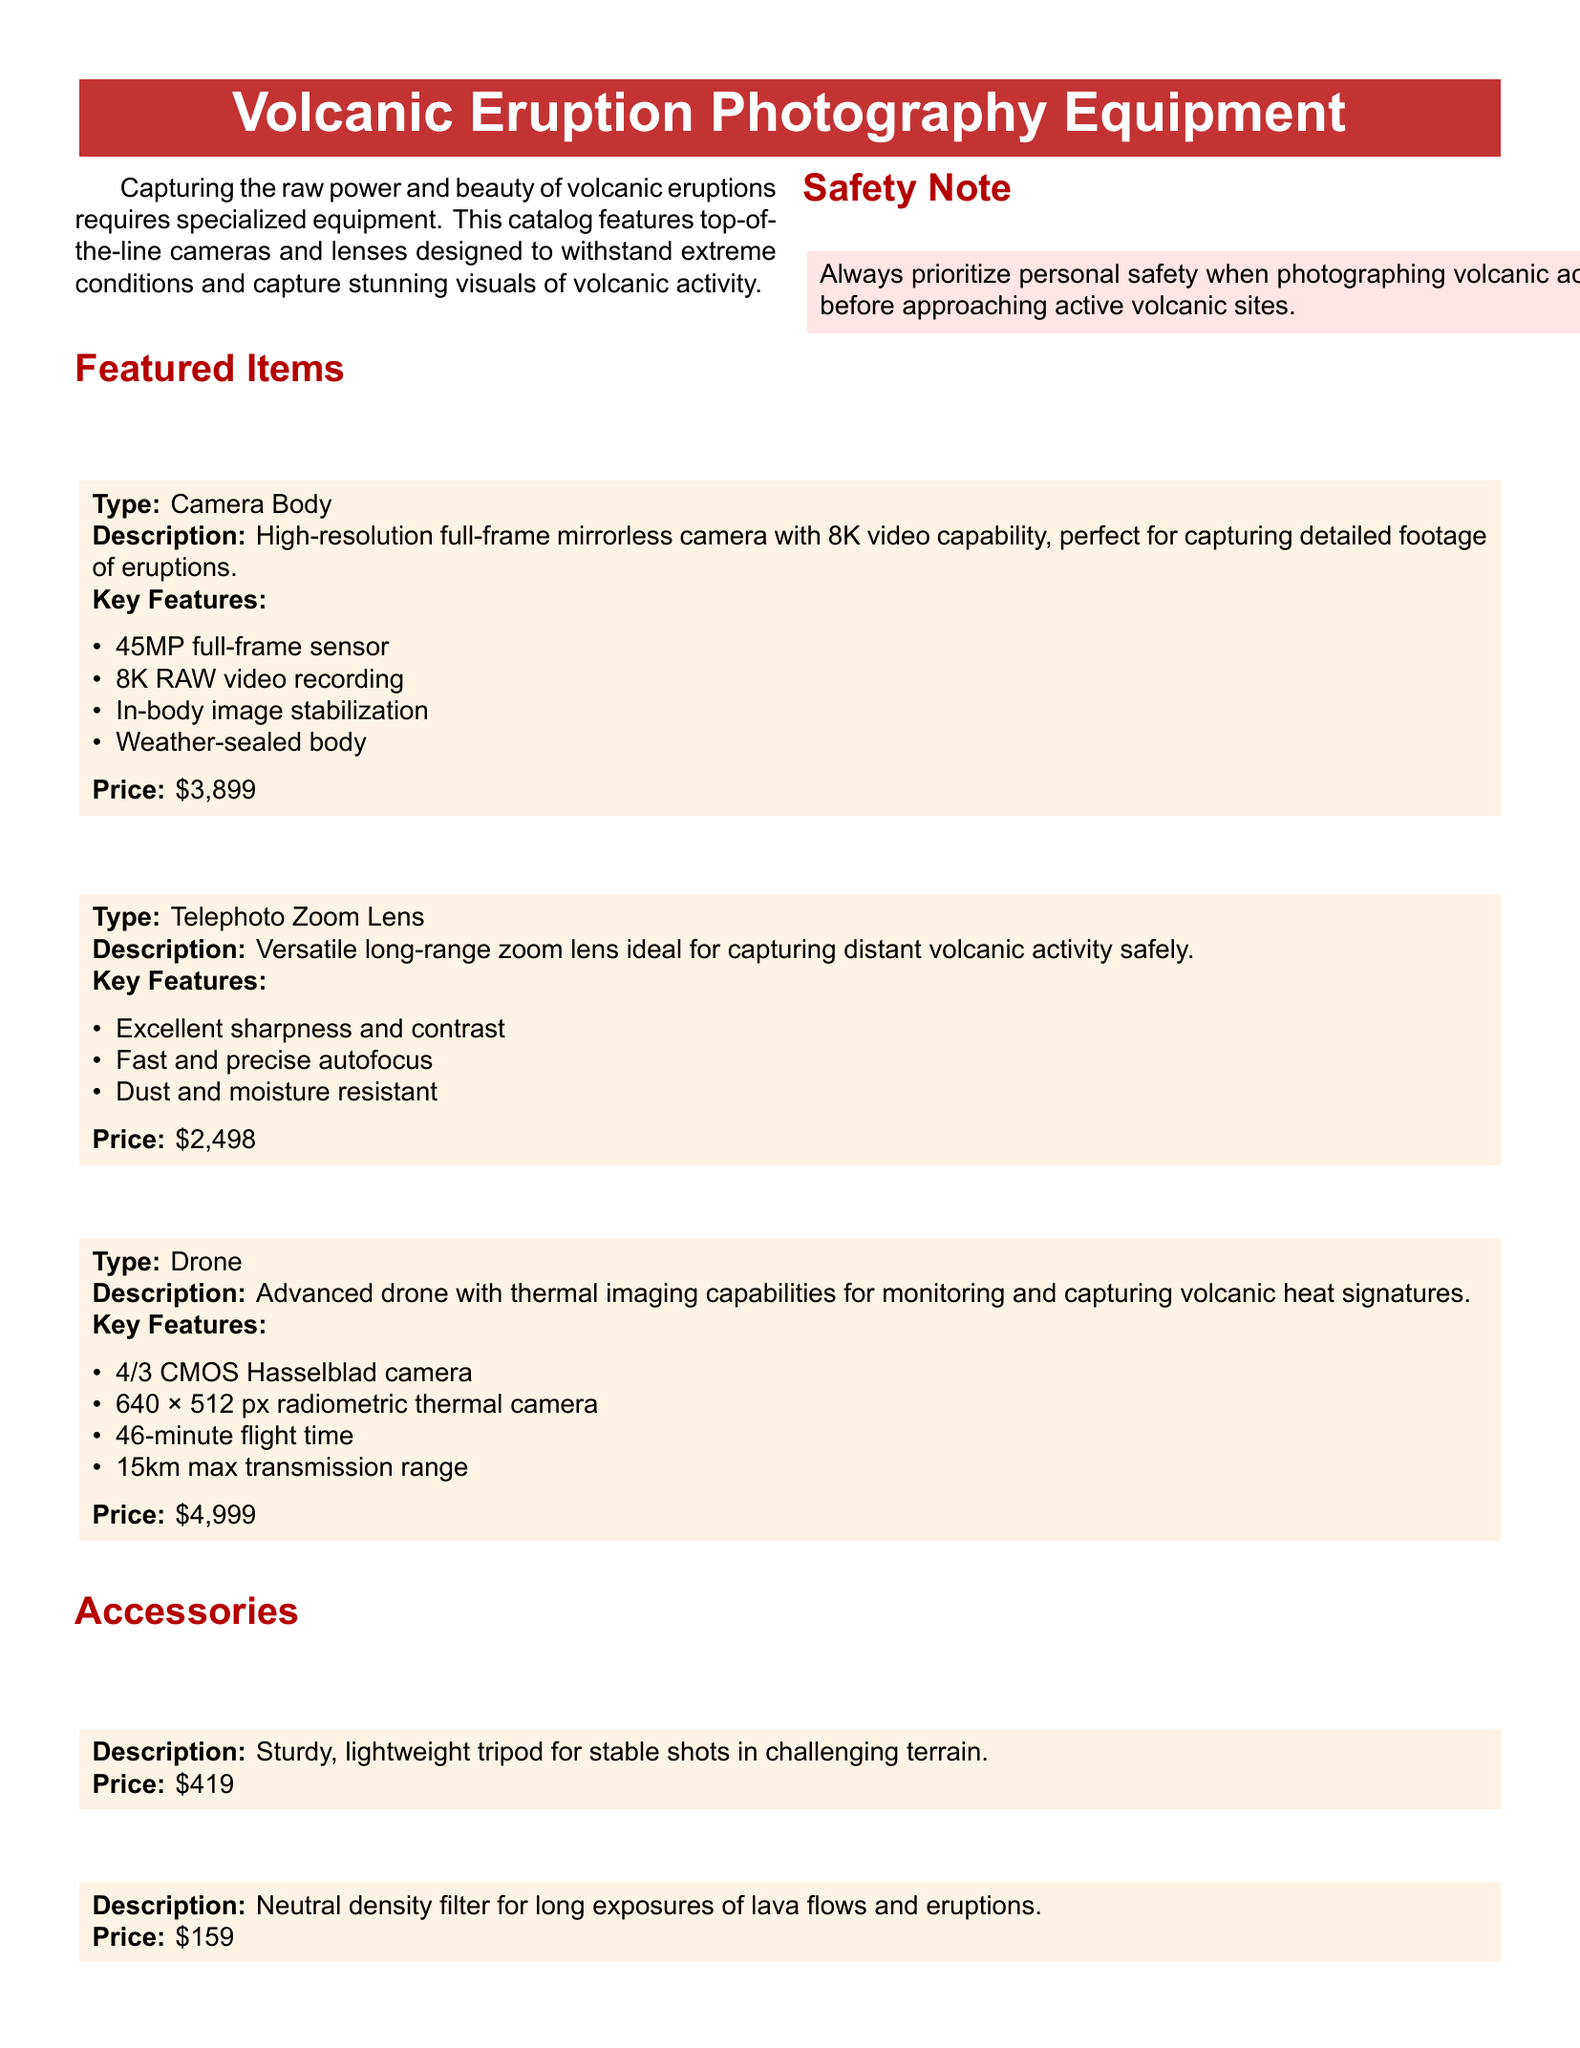What is the price of the Canon EOS R5? The price is listed directly beneath the description of the Canon EOS R5 in the document.
Answer: $3,899 What is the maximum transmission range of the DJI Mavic 3 Thermal? The maximum transmission range is specified in the details of the DJI Mavic 3 Thermal section.
Answer: 15km What type of lens is the Sony FE 100-400mm f/4.5-5.6 GM OSS? This information can be found in the title section of the Sony FE 100-400mm lens description.
Answer: Telephoto Zoom Lens Which accessory is designed for long exposures of lava flows? The specific accessory mentioned for long exposures is found under the accessories section.
Answer: HOYA SOLAS IRND 3.0 Filter How many megapixels does the Canon EOS R5's sensor have? The number of megapixels is part of the key features for the Canon EOS R5 camera body.
Answer: 45MP Which item has a 46-minute flight time? This detail is specifically described under the DJI Mavic 3 Thermal section in the document.
Answer: DJI Mavic 3 Thermal What does "weather-sealed" mean regarding the Canon EOS R5? Weather-sealed refers to the camera's ability to withstand environmental conditions, which is a safety feature highlighted in the Canon EOS R5 description.
Answer: In-body image stabilization What is the weight of the Manfrotto MT055CXPRO4 Carbon Fiber Tripod? The weight is not mentioned in the document; it focuses on sturdiness and lightweight features.
Answer: Not specified What safety note is included in this catalog? The catalog includes a specific safety note that emphasizes personal safety when photographing volcanic activity.
Answer: Prioritize personal safety when photographing volcanic activity 